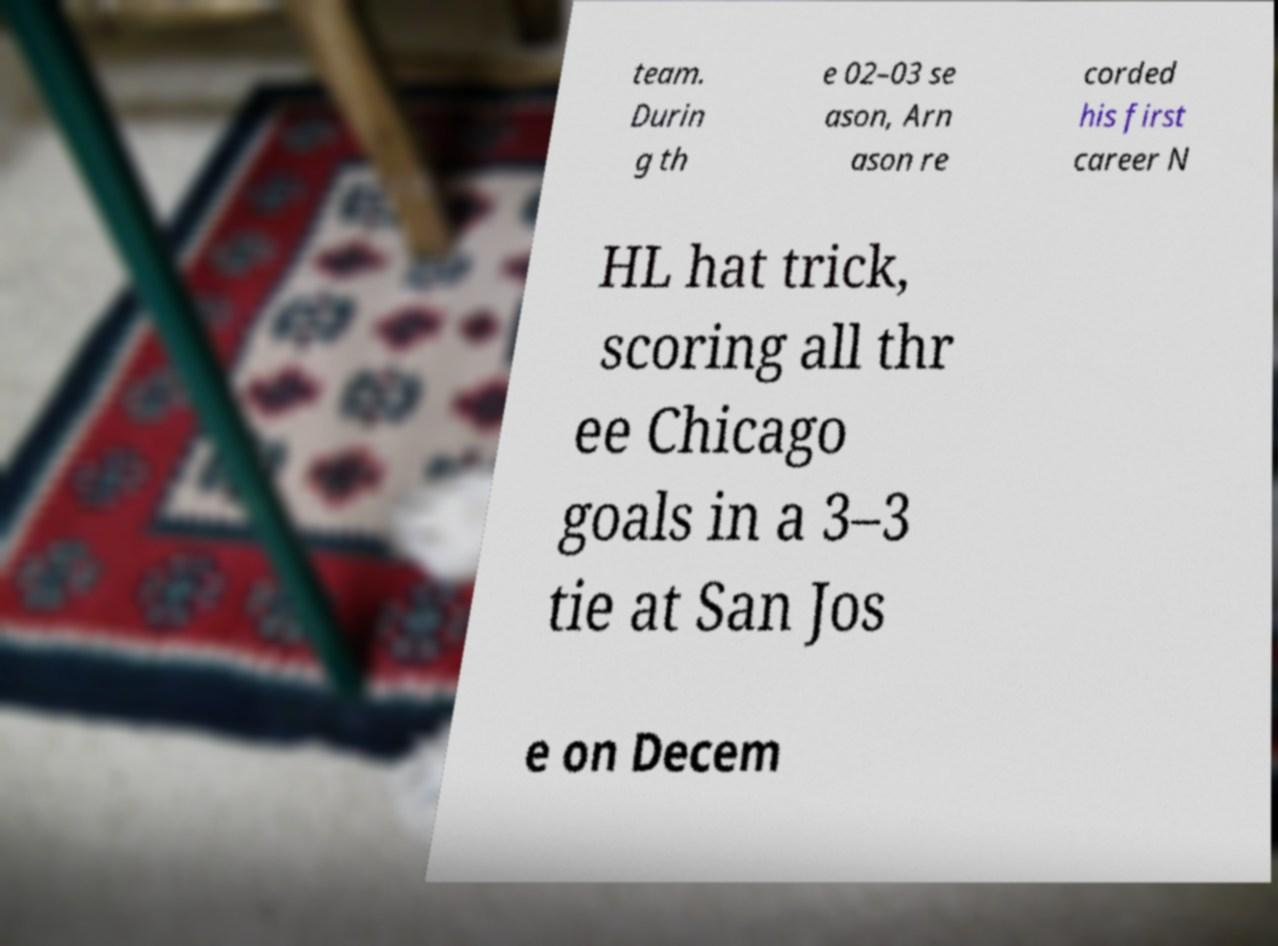Could you assist in decoding the text presented in this image and type it out clearly? team. Durin g th e 02–03 se ason, Arn ason re corded his first career N HL hat trick, scoring all thr ee Chicago goals in a 3–3 tie at San Jos e on Decem 